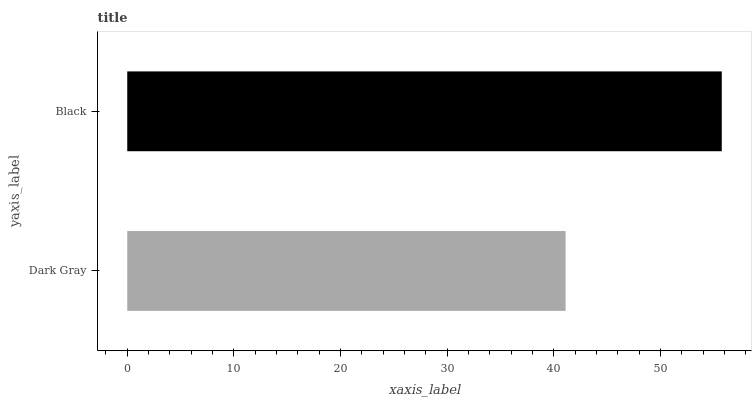Is Dark Gray the minimum?
Answer yes or no. Yes. Is Black the maximum?
Answer yes or no. Yes. Is Black the minimum?
Answer yes or no. No. Is Black greater than Dark Gray?
Answer yes or no. Yes. Is Dark Gray less than Black?
Answer yes or no. Yes. Is Dark Gray greater than Black?
Answer yes or no. No. Is Black less than Dark Gray?
Answer yes or no. No. Is Black the high median?
Answer yes or no. Yes. Is Dark Gray the low median?
Answer yes or no. Yes. Is Dark Gray the high median?
Answer yes or no. No. Is Black the low median?
Answer yes or no. No. 